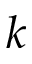<formula> <loc_0><loc_0><loc_500><loc_500>k</formula> 